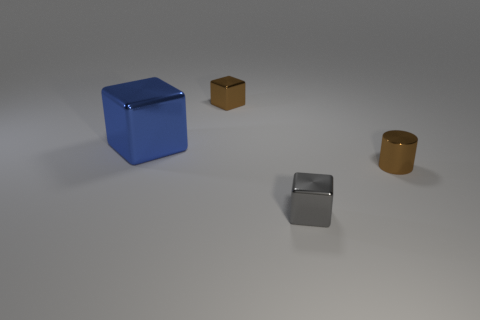Subtract all gray blocks. How many blocks are left? 2 Add 2 large red matte objects. How many objects exist? 6 Subtract all blue blocks. How many blocks are left? 2 Subtract 1 cubes. How many cubes are left? 2 Subtract all cubes. How many objects are left? 1 Subtract all cyan cylinders. Subtract all purple cubes. How many cylinders are left? 1 Subtract all large metallic things. Subtract all cyan shiny spheres. How many objects are left? 3 Add 3 brown shiny cylinders. How many brown shiny cylinders are left? 4 Add 4 gray metallic blocks. How many gray metallic blocks exist? 5 Subtract 1 brown blocks. How many objects are left? 3 